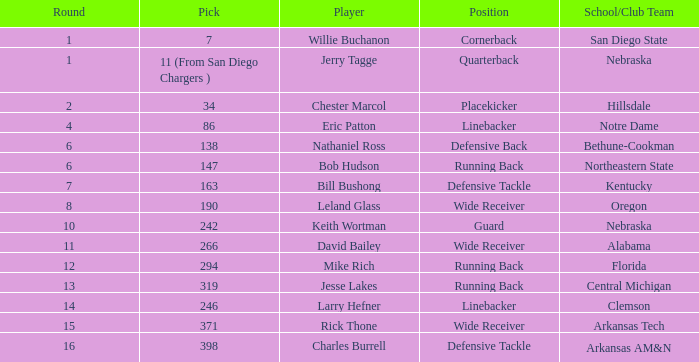In what round can the cornerback position be found? 1.0. 